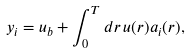Convert formula to latex. <formula><loc_0><loc_0><loc_500><loc_500>y _ { i } = u _ { b } + \int _ { 0 } ^ { T } d r \, u ( r ) a _ { i } ( r ) ,</formula> 